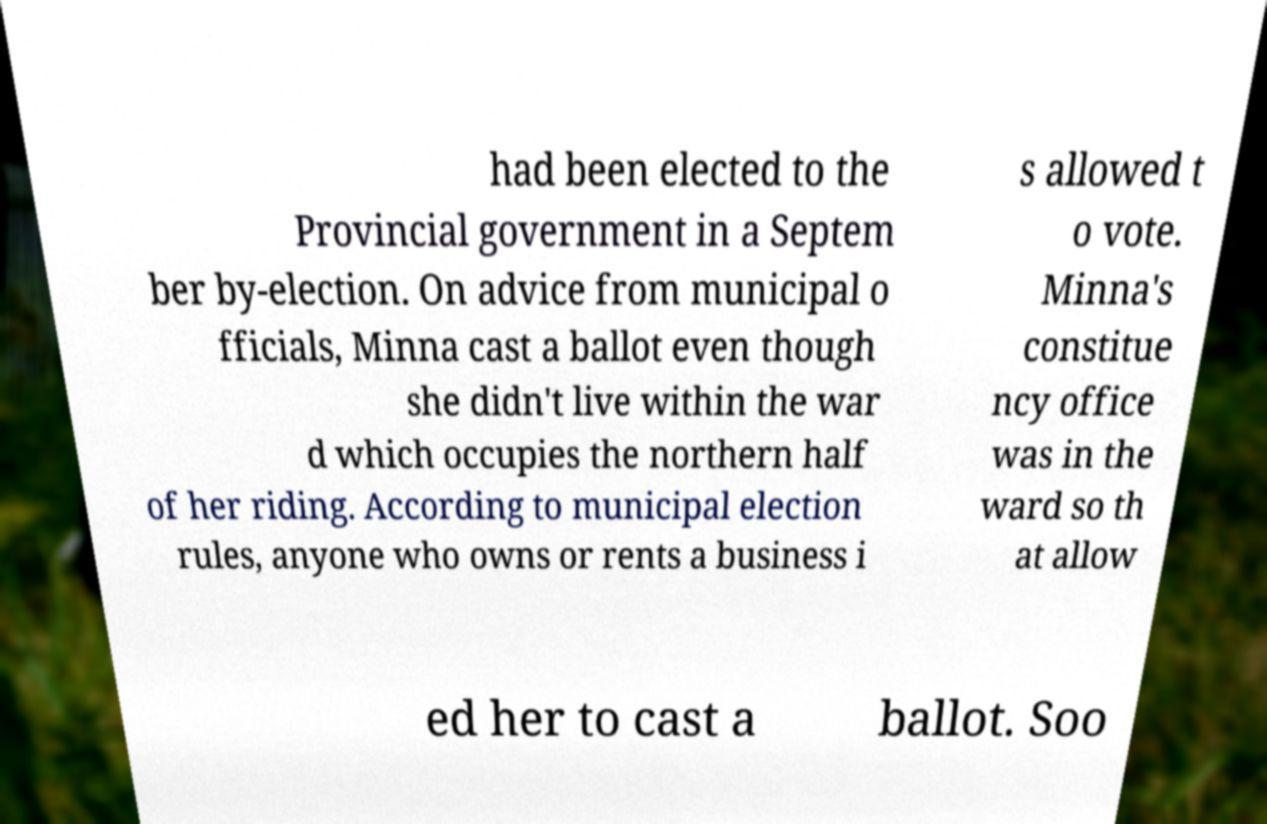Can you read and provide the text displayed in the image?This photo seems to have some interesting text. Can you extract and type it out for me? had been elected to the Provincial government in a Septem ber by-election. On advice from municipal o fficials, Minna cast a ballot even though she didn't live within the war d which occupies the northern half of her riding. According to municipal election rules, anyone who owns or rents a business i s allowed t o vote. Minna's constitue ncy office was in the ward so th at allow ed her to cast a ballot. Soo 